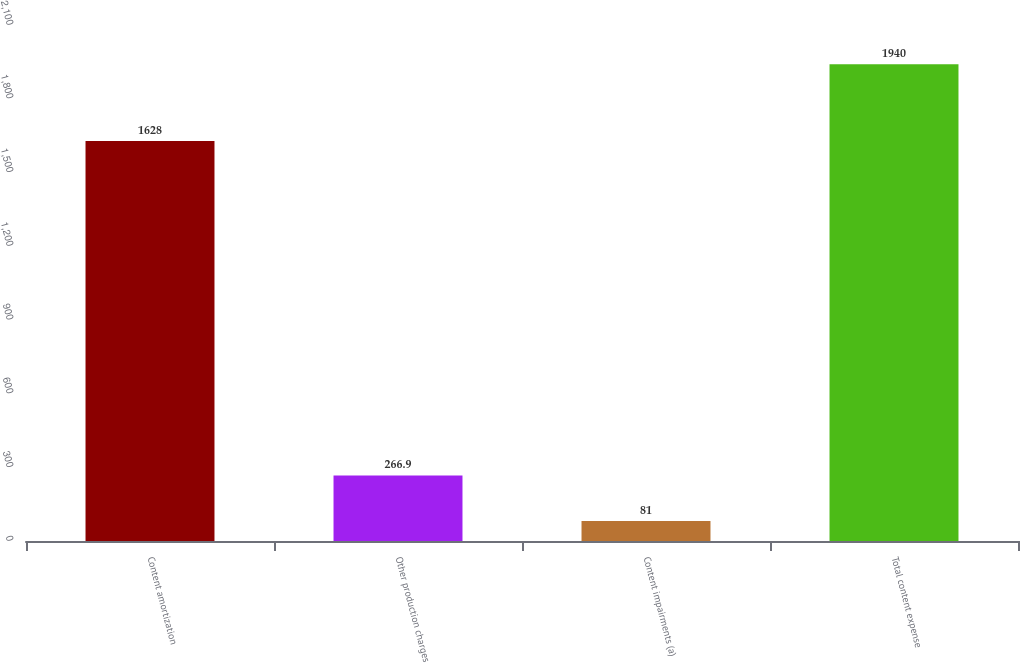Convert chart to OTSL. <chart><loc_0><loc_0><loc_500><loc_500><bar_chart><fcel>Content amortization<fcel>Other production charges<fcel>Content impairments (a)<fcel>Total content expense<nl><fcel>1628<fcel>266.9<fcel>81<fcel>1940<nl></chart> 